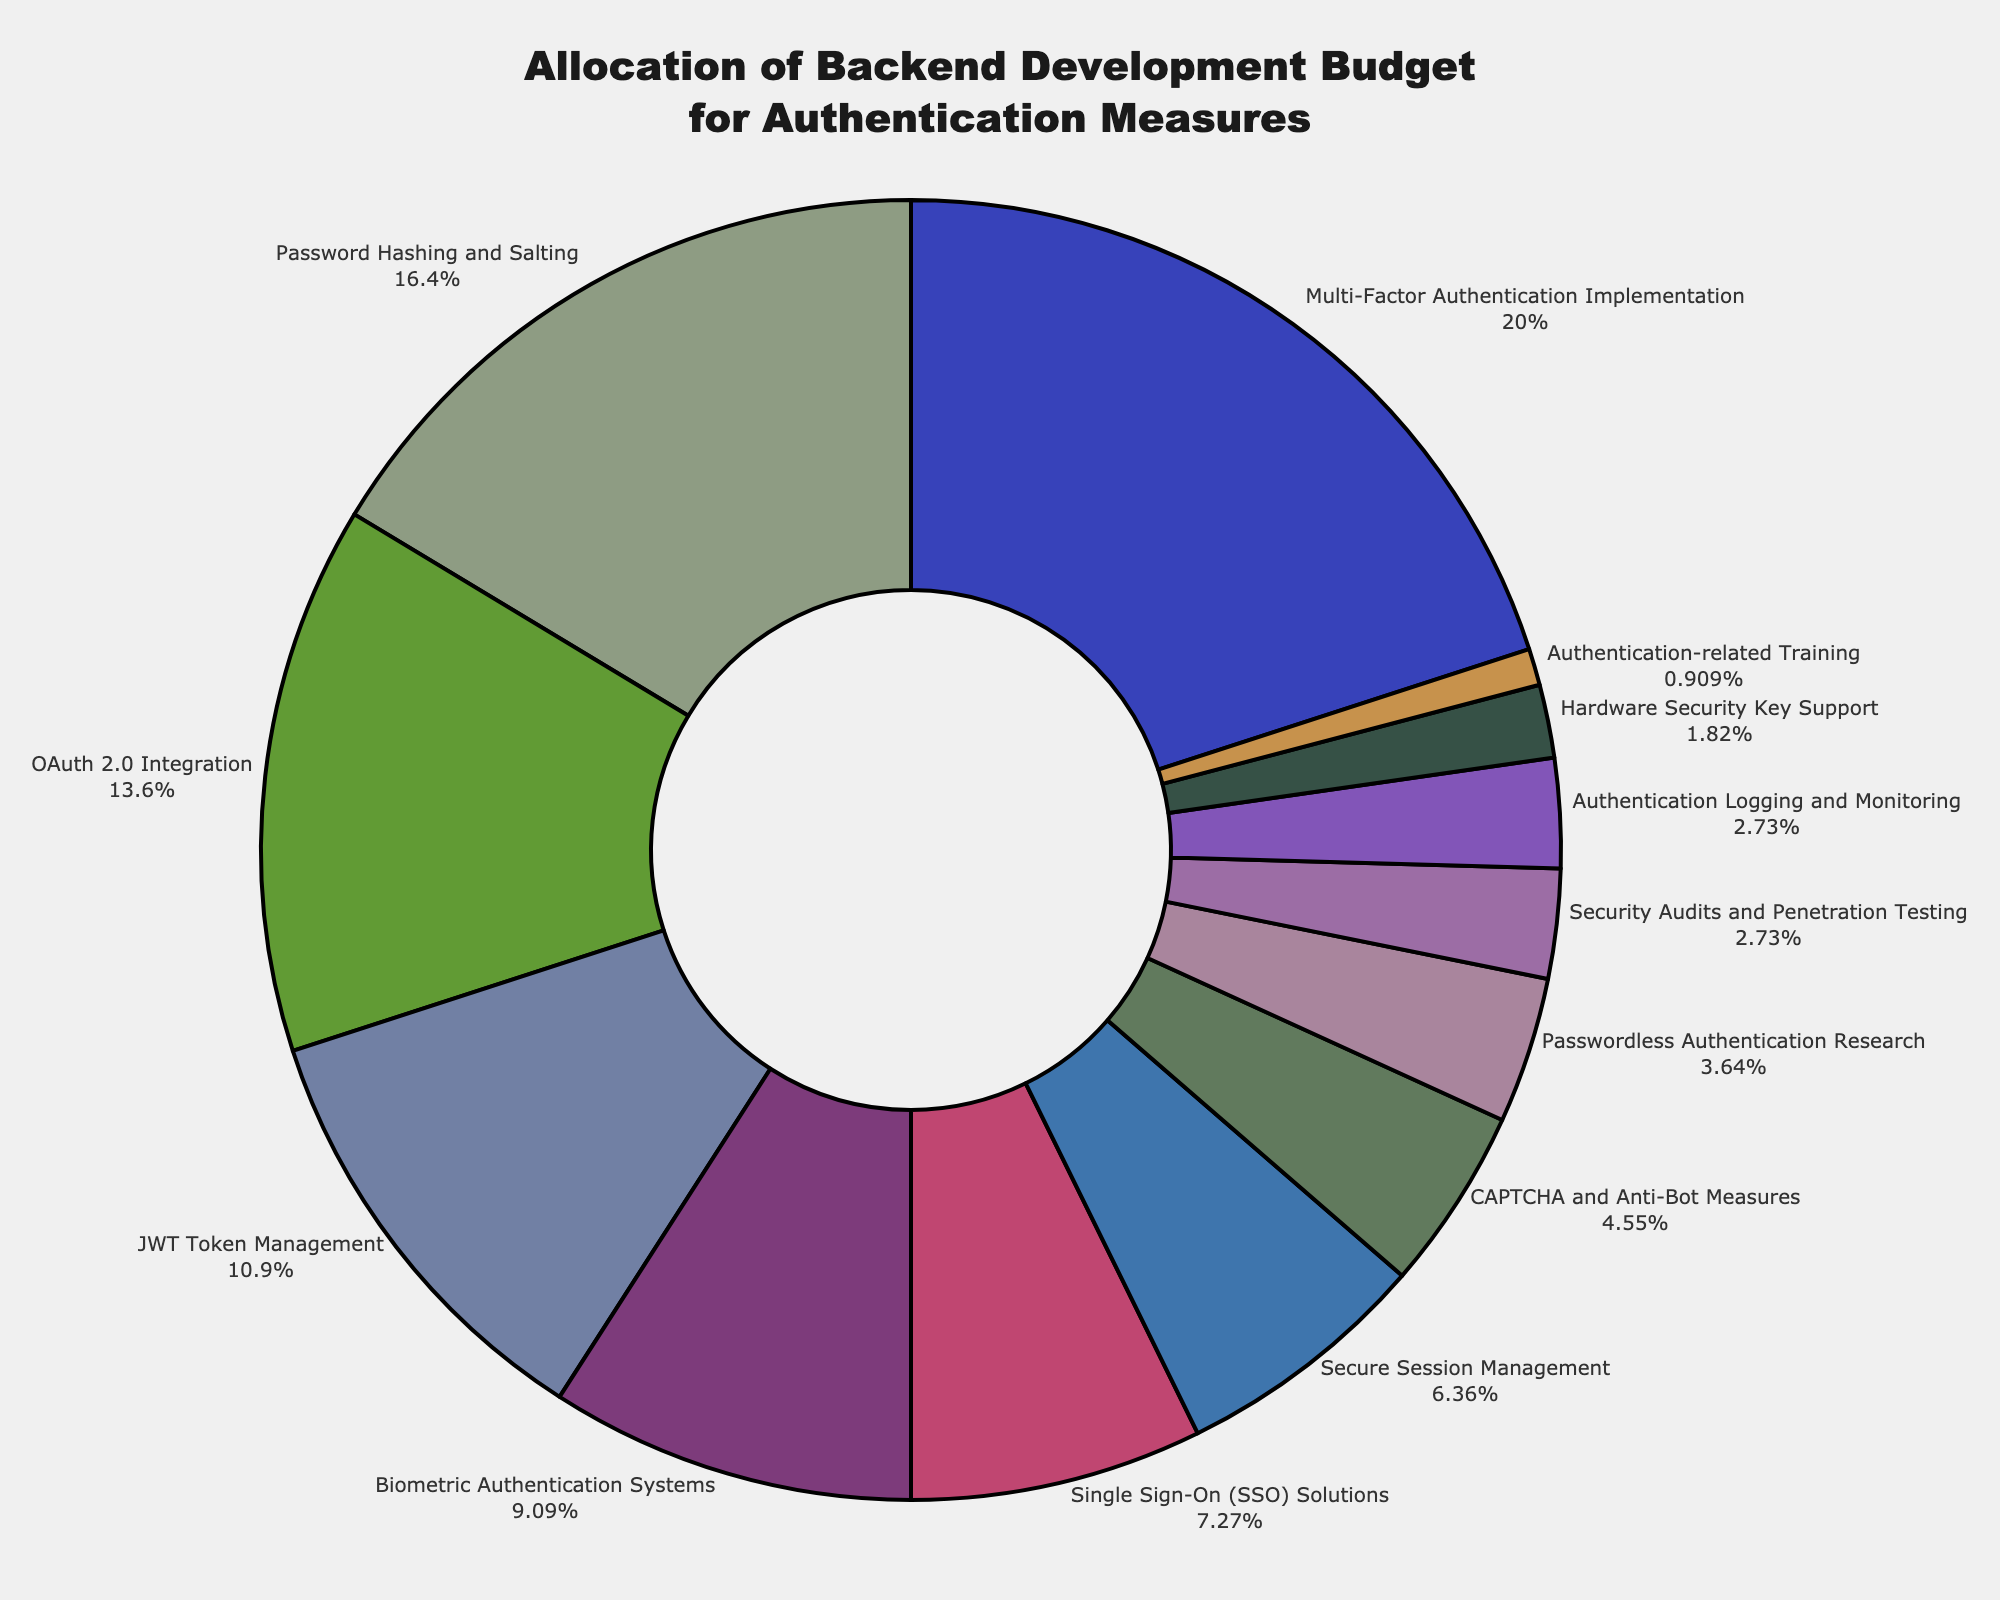Which category has the highest allocation of the backend development budget? The category with the highest allocation is the one with the largest percentage on the pie chart, which is Multi-Factor Authentication Implementation.
Answer: Multi-Factor Authentication Implementation Which two categories have the smallest allocations, and what are their combined percentages? The smallest allocations are Authentication-related Training at 1% and Hardware Security Key Support at 2%. Their combined percentage is 1% + 2% = 3%.
Answer: Authentication-related Training and Hardware Security Key Support at 3% How much more is allocated to Multi-Factor Authentication Implementation compared to OAuth 2.0 Integration? Multi-Factor Authentication Implementation is allocated 22%, and OAuth 2.0 Integration is allocated 15%. The difference is 22% - 15% = 7%.
Answer: 7% What percentage of the budget is allocated to Biometric Authentication Systems and Passwordless Authentication Research combined? Biometric Authentication Systems are allocated 10%, and Passwordless Authentication Research is allocated 4%. Their combined percentage is 10% + 4% = 14%.
Answer: 14% How many categories have an allocation percentage of 10% or more? The categories are Multi-Factor Authentication Implementation (22%), Password Hashing and Salting (18%), OAuth 2.0 Integration (15%), JWT Token Management (12%), and Biometric Authentication Systems (10%). There are 5 such categories.
Answer: 5 What is the average allocation percentage for Secure Session Management, CAPTCHA and Anti-Bot Measures, and Authentication Logging and Monitoring? The allocation percentages are 7%, 5%, and 3%, respectively. The average is calculated as (7% + 5% + 3%) / 3 = 15% / 3 = 5%.
Answer: 5% Which category is represented by a lighter blue color and what is its allocation percentage? The color description points to the CAPTCHA and Anti-Bot Measures category, which has an allocation of 5%.
Answer: CAPTCHA and Anti-Bot Measures at 5% Compare the allocation for Single Sign-On (SSO) Solutions and JWT Token Management. Which is higher, and by how much? Single Sign-On (SSO) Solutions are allocated 8%, and JWT Token Management is allocated 12%. JWT Token Management is higher by 12% - 8% = 4%.
Answer: JWT Token Management by 4% Summing the allocations for JWT Token Management, Biometric Authentication Systems, Secure Session Management, and CAPTCHA and Anti-Bot Measures, what is the total percentage? The allocations are JWT Token Management (12%), Biometric Authentication Systems (10%), Secure Session Management (7%), and CAPTCHA and Anti-Bot Measures (5%). The total is 12% + 10% + 7% + 5% = 34%.
Answer: 34% 